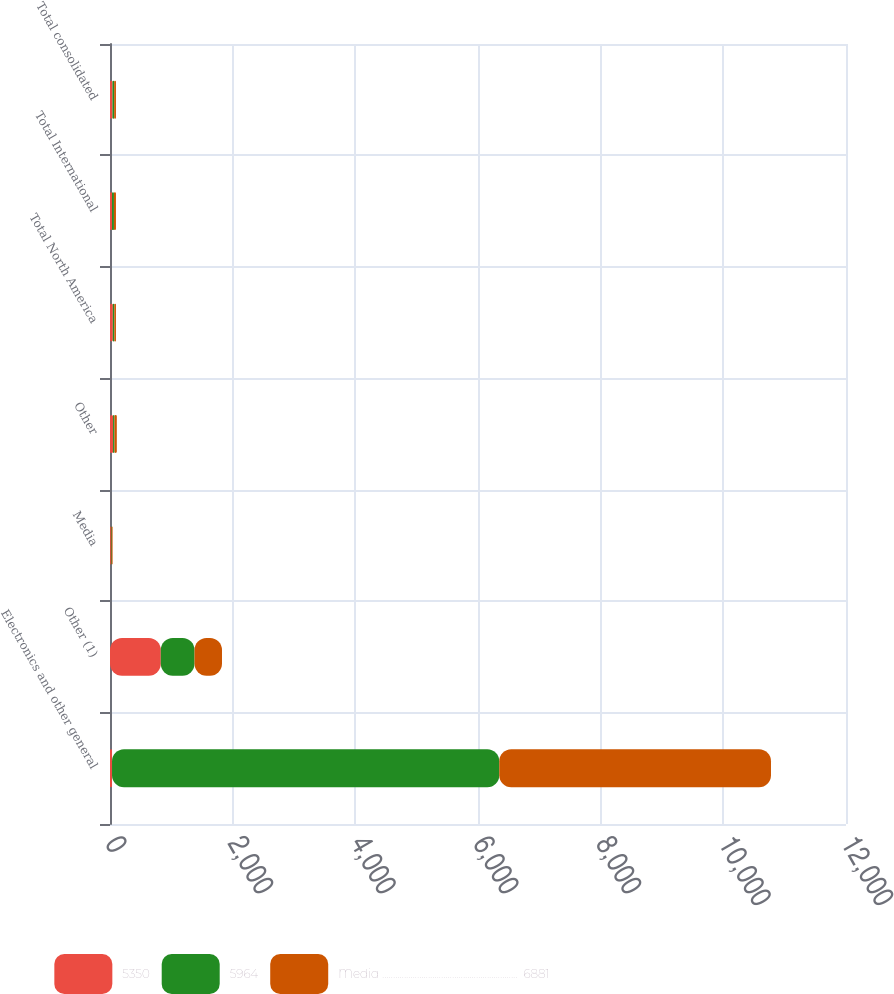<chart> <loc_0><loc_0><loc_500><loc_500><stacked_bar_chart><ecel><fcel>Electronics and other general<fcel>Other (1)<fcel>Media<fcel>Other<fcel>Total North America<fcel>Total International<fcel>Total consolidated<nl><fcel>5350<fcel>33<fcel>828<fcel>15<fcel>50<fcel>46<fcel>33<fcel>40<nl><fcel>5964<fcel>6314<fcel>550<fcel>11<fcel>23<fcel>25<fcel>31<fcel>28<nl><fcel>Media ..............................................................  6881<fcel>4430<fcel>448<fcel>16<fcel>38<fcel>26<fcel>33<fcel>29<nl></chart> 